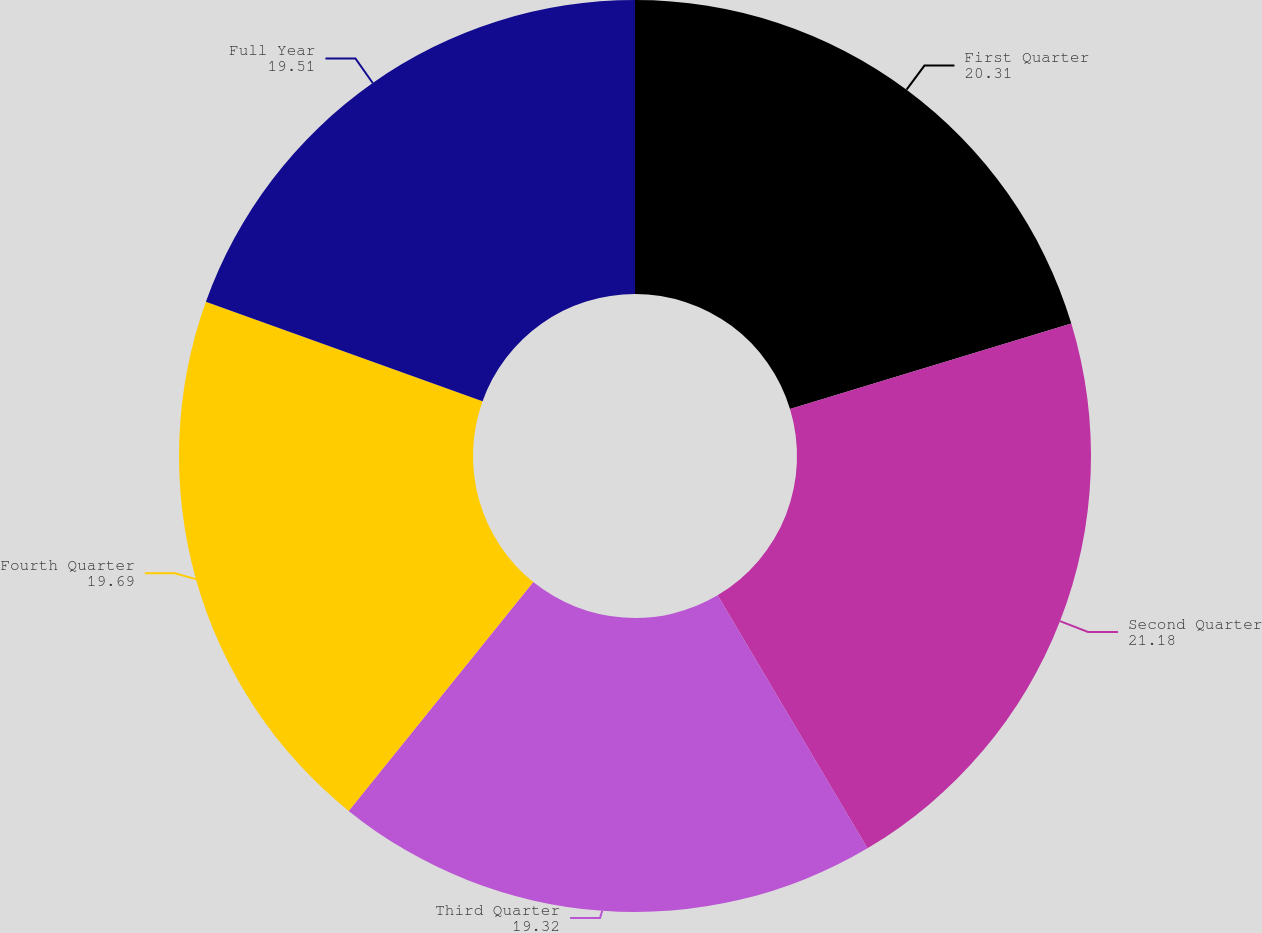<chart> <loc_0><loc_0><loc_500><loc_500><pie_chart><fcel>First Quarter<fcel>Second Quarter<fcel>Third Quarter<fcel>Fourth Quarter<fcel>Full Year<nl><fcel>20.31%<fcel>21.18%<fcel>19.32%<fcel>19.69%<fcel>19.51%<nl></chart> 